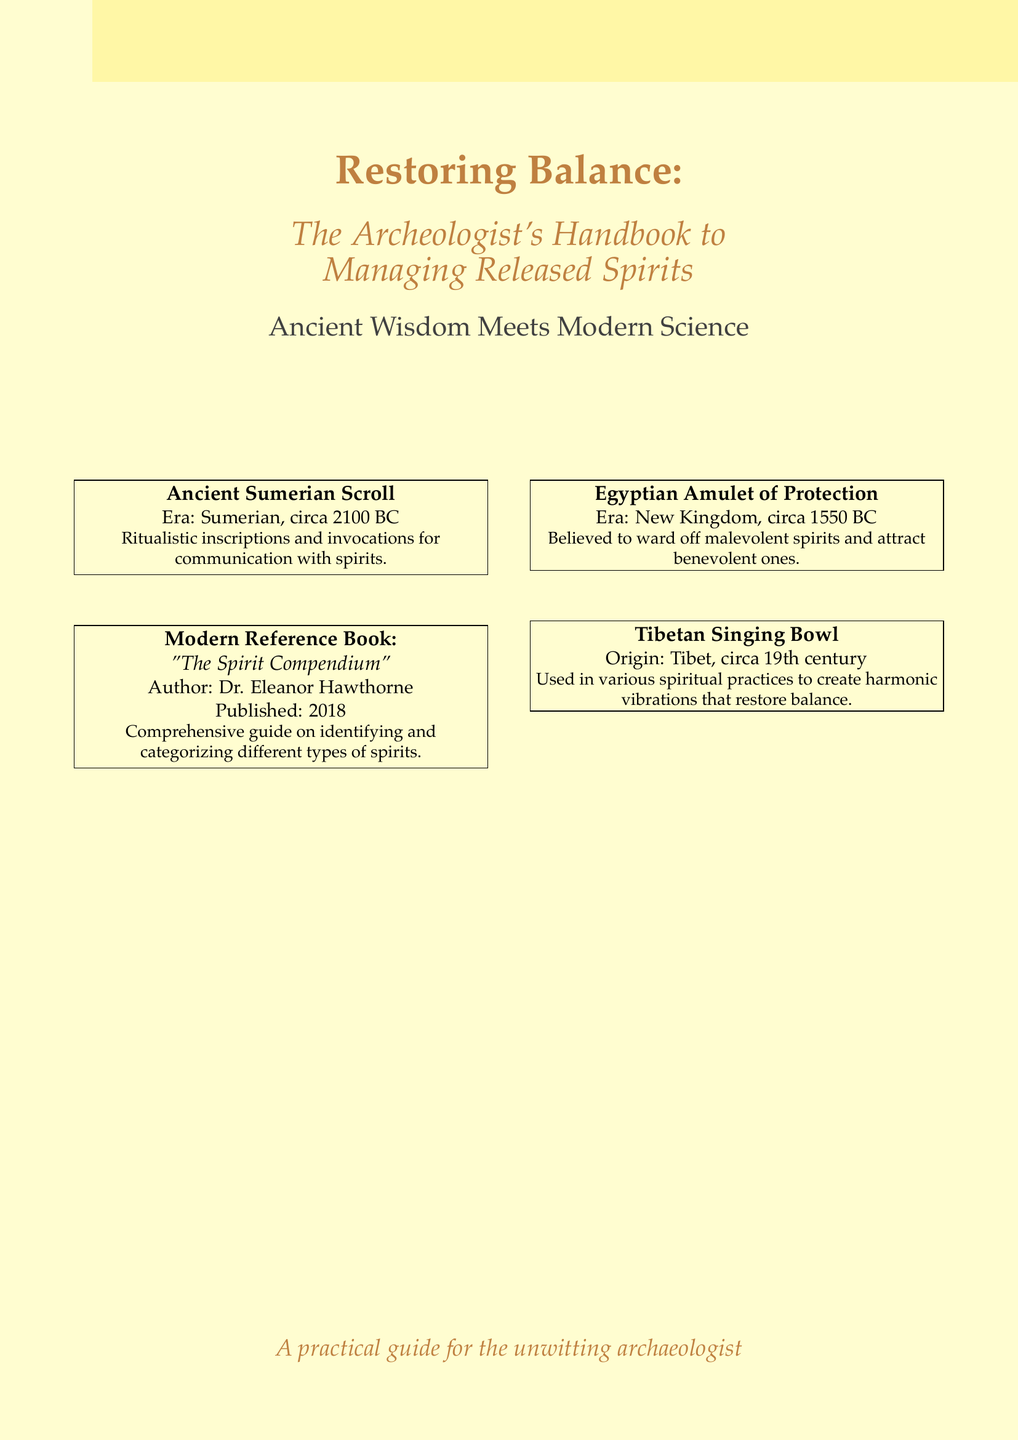What is the title of the book? The title is prominently displayed at the top of the document.
Answer: Restoring Balance Who is the author of "The Spirit Compendium"? The document lists the author right below the book title.
Answer: Dr. Eleanor Hawthorne What is the era of the Sumerian Scroll? The era is specified in the box describing the ancient scroll.
Answer: Sumerian, circa 2100 BC What type of spiritual artifact is described as being from the New Kingdom? This is mentioned in the section about the Egyptian amulet.
Answer: Amulet of Protection How many reference books are mentioned on the cover? The document includes two modern reference books.
Answer: One What does the Tibetan Singing Bowl create to restore balance? The document provides this detail in the description of the Tibetan artifact.
Answer: Harmonic vibrations What does the Egyptian Amulet of Protection ward off? The text explains the protective nature of the amulet.
Answer: Malevolent spirits What year was "The Spirit Compendium" published? The publication year is included in the description of the modern reference book.
Answer: 2018 